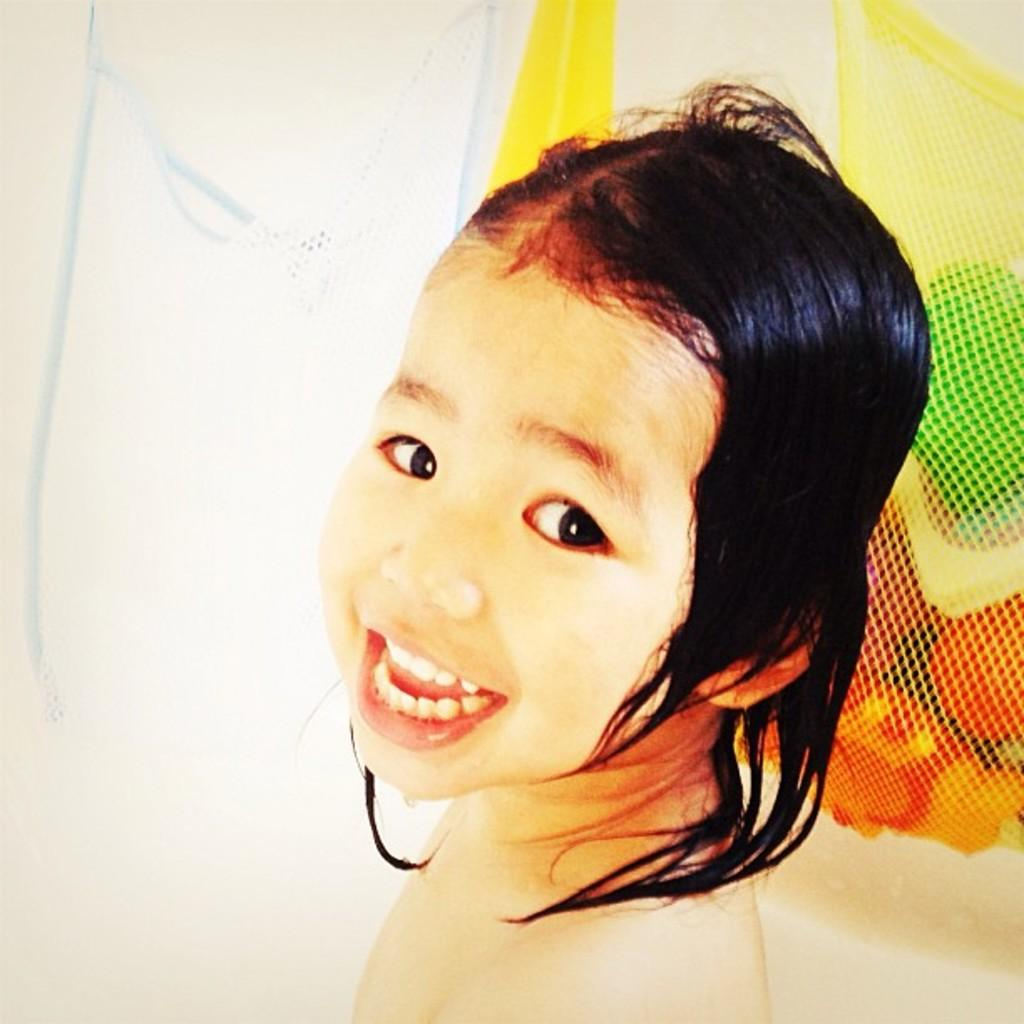What is the main subject of the image? The main subject of the image is a kid. What can be seen on the right side of the image? There is a yellow net bag with toys in it on the right side of the image. What type of plastic is visible in the pocket of the kid's arm in the image? There is no plastic visible in the pocket of the kid's arm in the image, as the provided facts do not mention any pockets or plastic objects. 